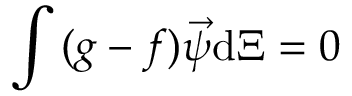<formula> <loc_0><loc_0><loc_500><loc_500>\int { ( g - f ) \vec { \psi } d \Xi } = 0</formula> 